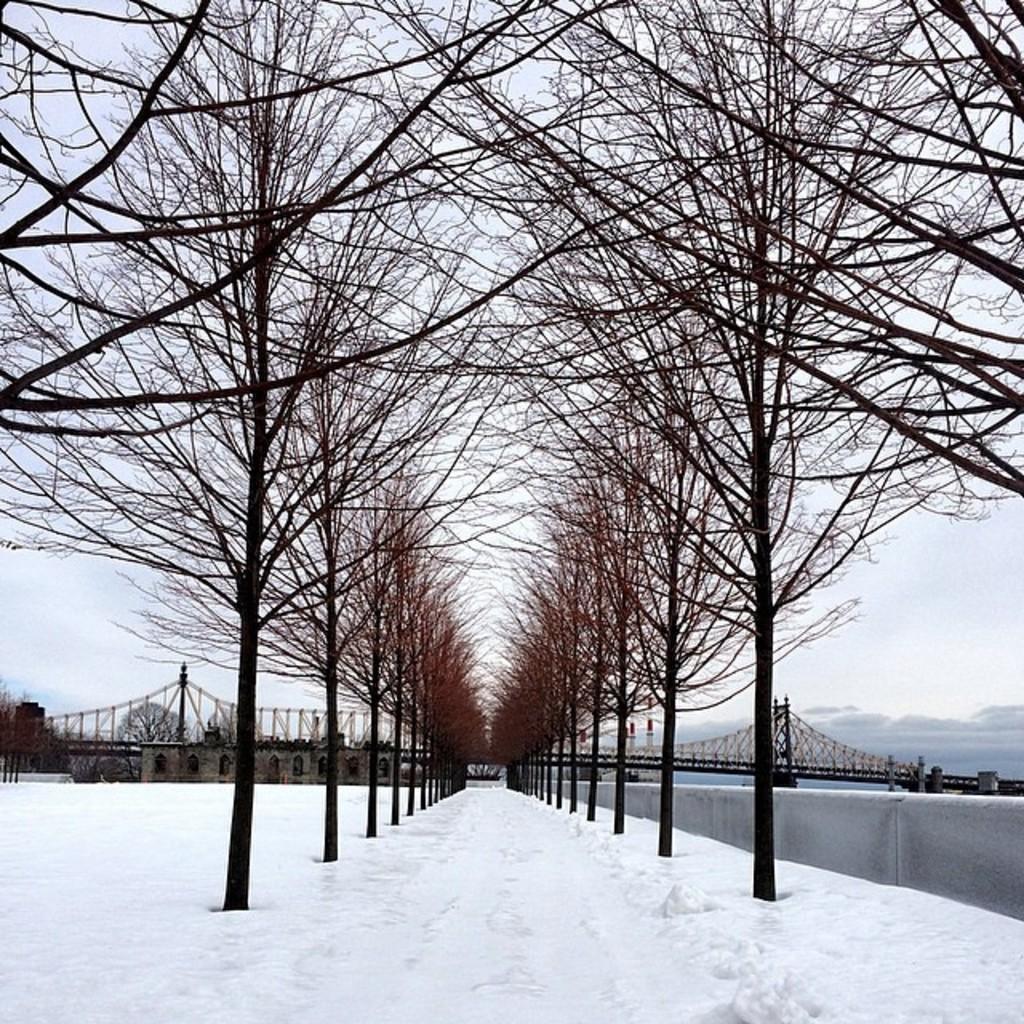Can you describe this image briefly? In this picture there is a building and there is a bridge and there are trees. At the top there is sky and there are clouds. At the bottom there is snow and water. 